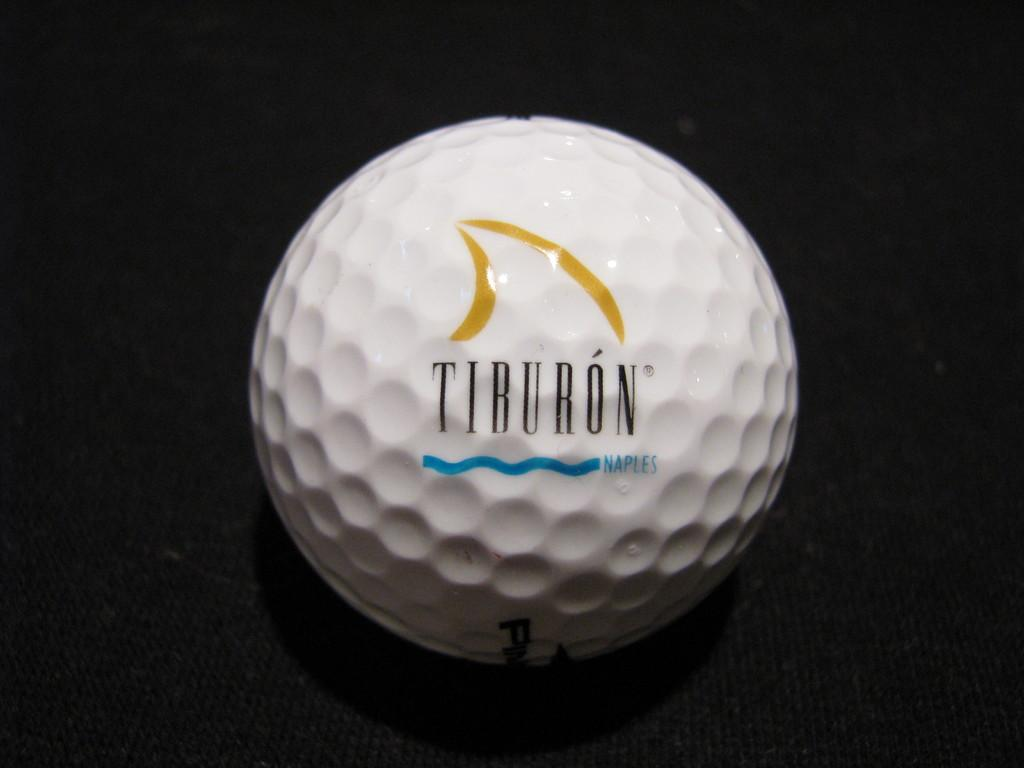<image>
Create a compact narrative representing the image presented. A white golf ball says Tiburon Naples on it. 